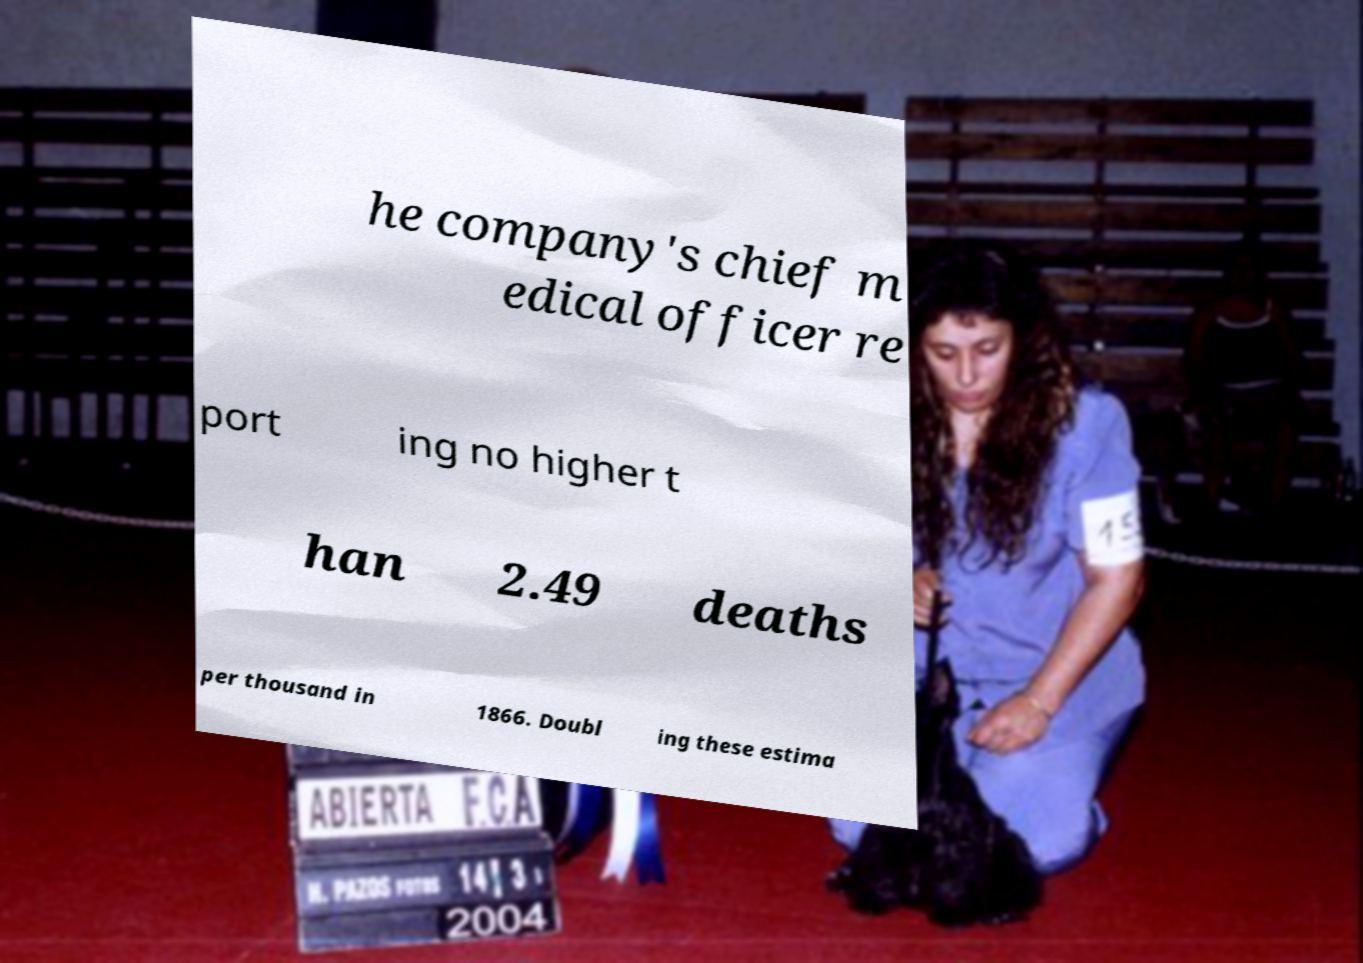Can you accurately transcribe the text from the provided image for me? he company's chief m edical officer re port ing no higher t han 2.49 deaths per thousand in 1866. Doubl ing these estima 